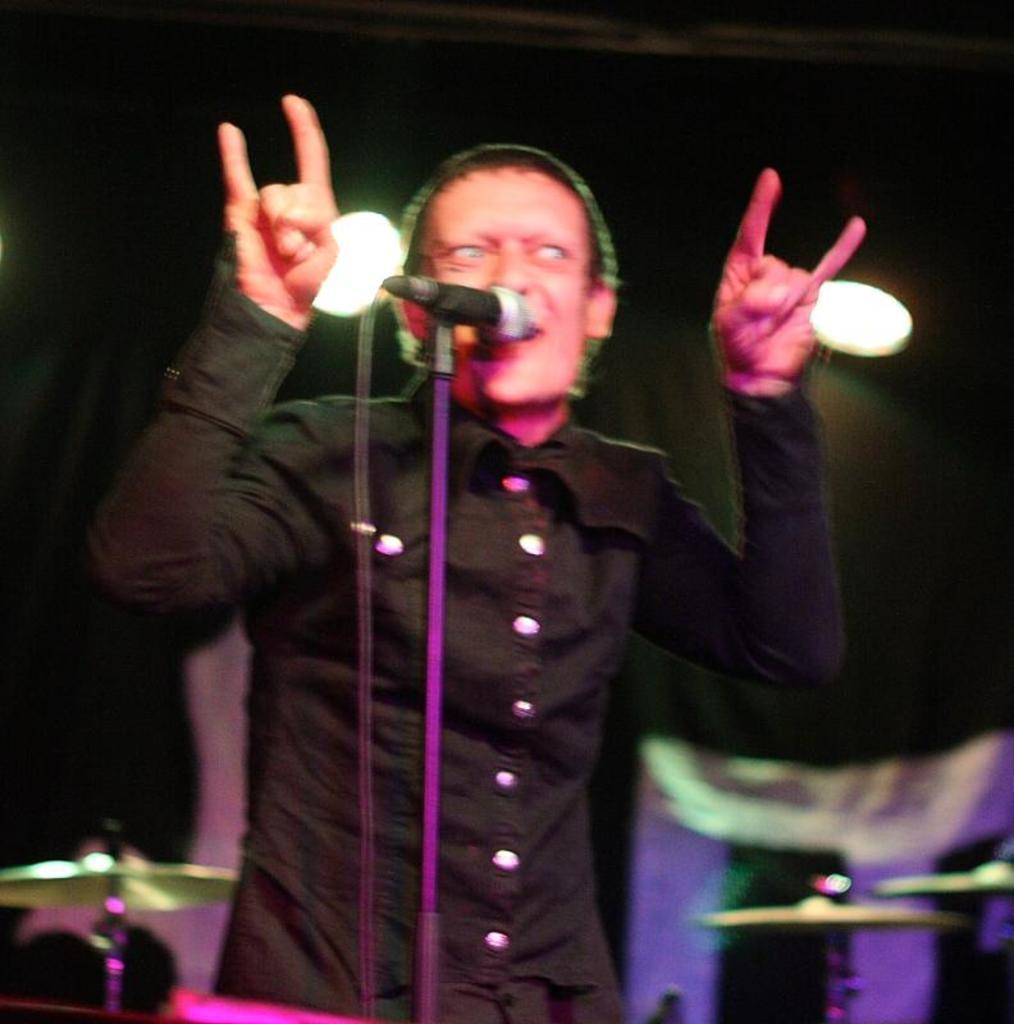In one or two sentences, can you explain what this image depicts? This image is taken in a concert. In the middle of the image a man is standing and singing in a mic. In the left and right side of the image there are musical instruments. In the background there are lights. 